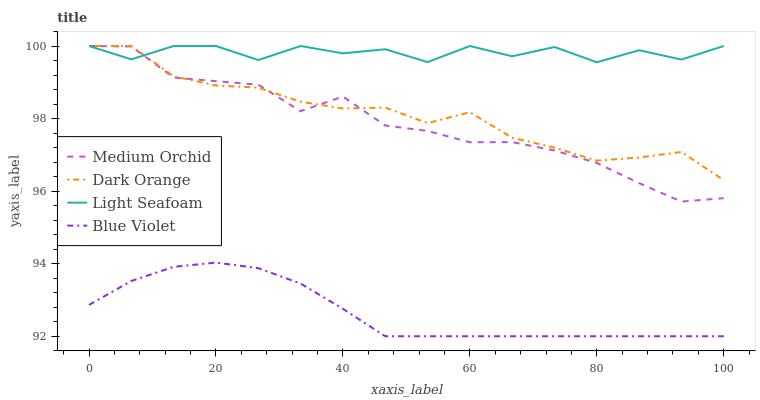Does Blue Violet have the minimum area under the curve?
Answer yes or no. Yes. Does Light Seafoam have the maximum area under the curve?
Answer yes or no. Yes. Does Medium Orchid have the minimum area under the curve?
Answer yes or no. No. Does Medium Orchid have the maximum area under the curve?
Answer yes or no. No. Is Blue Violet the smoothest?
Answer yes or no. Yes. Is Light Seafoam the roughest?
Answer yes or no. Yes. Is Medium Orchid the smoothest?
Answer yes or no. No. Is Medium Orchid the roughest?
Answer yes or no. No. Does Blue Violet have the lowest value?
Answer yes or no. Yes. Does Medium Orchid have the lowest value?
Answer yes or no. No. Does Light Seafoam have the highest value?
Answer yes or no. Yes. Does Blue Violet have the highest value?
Answer yes or no. No. Is Blue Violet less than Dark Orange?
Answer yes or no. Yes. Is Medium Orchid greater than Blue Violet?
Answer yes or no. Yes. Does Medium Orchid intersect Dark Orange?
Answer yes or no. Yes. Is Medium Orchid less than Dark Orange?
Answer yes or no. No. Is Medium Orchid greater than Dark Orange?
Answer yes or no. No. Does Blue Violet intersect Dark Orange?
Answer yes or no. No. 